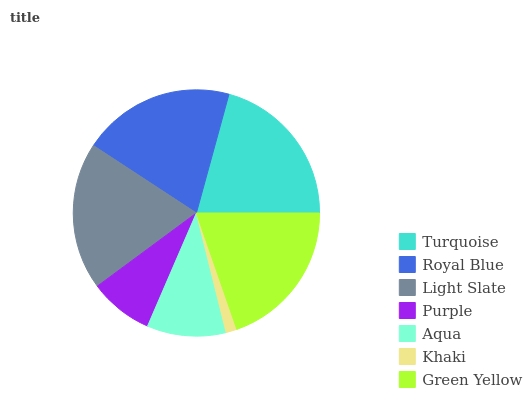Is Khaki the minimum?
Answer yes or no. Yes. Is Turquoise the maximum?
Answer yes or no. Yes. Is Royal Blue the minimum?
Answer yes or no. No. Is Royal Blue the maximum?
Answer yes or no. No. Is Turquoise greater than Royal Blue?
Answer yes or no. Yes. Is Royal Blue less than Turquoise?
Answer yes or no. Yes. Is Royal Blue greater than Turquoise?
Answer yes or no. No. Is Turquoise less than Royal Blue?
Answer yes or no. No. Is Light Slate the high median?
Answer yes or no. Yes. Is Light Slate the low median?
Answer yes or no. Yes. Is Green Yellow the high median?
Answer yes or no. No. Is Khaki the low median?
Answer yes or no. No. 